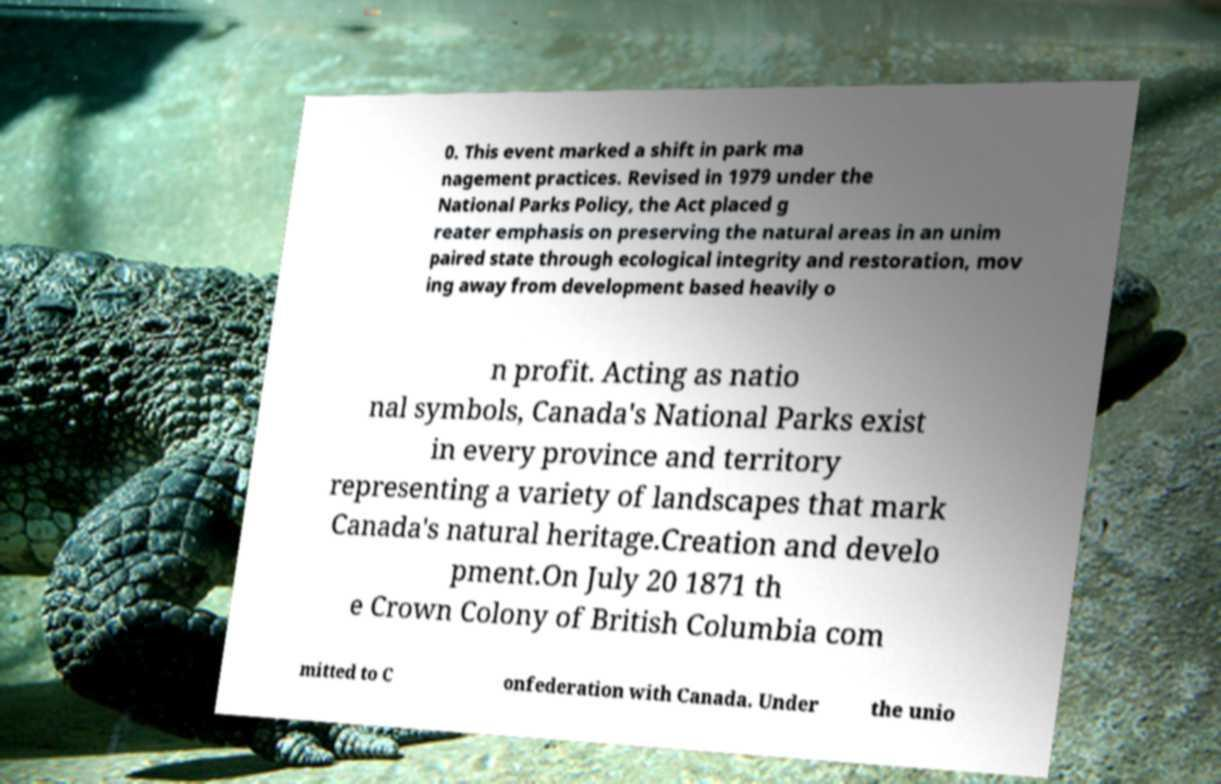Could you assist in decoding the text presented in this image and type it out clearly? 0. This event marked a shift in park ma nagement practices. Revised in 1979 under the National Parks Policy, the Act placed g reater emphasis on preserving the natural areas in an unim paired state through ecological integrity and restoration, mov ing away from development based heavily o n profit. Acting as natio nal symbols, Canada's National Parks exist in every province and territory representing a variety of landscapes that mark Canada's natural heritage.Creation and develo pment.On July 20 1871 th e Crown Colony of British Columbia com mitted to C onfederation with Canada. Under the unio 